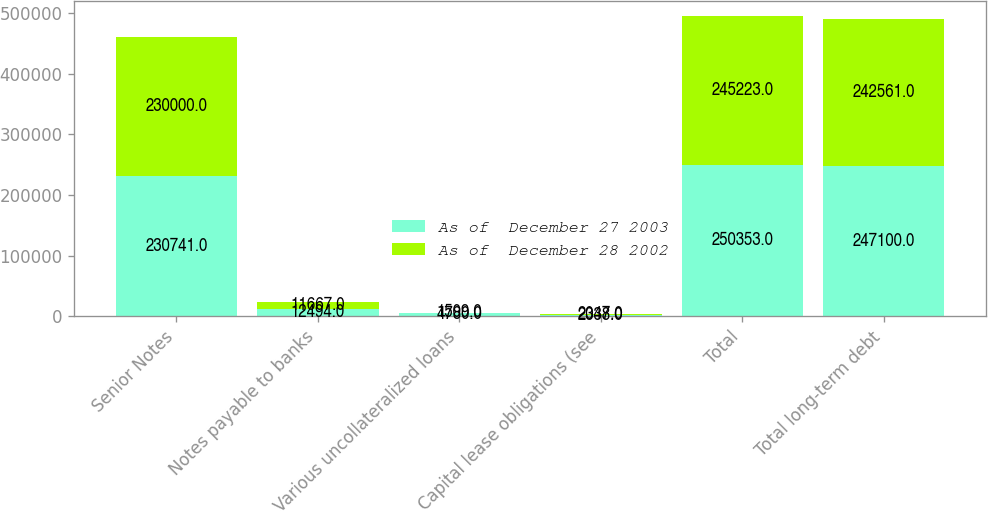Convert chart. <chart><loc_0><loc_0><loc_500><loc_500><stacked_bar_chart><ecel><fcel>Senior Notes<fcel>Notes payable to banks<fcel>Various uncollateralized loans<fcel>Capital lease obligations (see<fcel>Total<fcel>Total long-term debt<nl><fcel>As of  December 27 2003<fcel>230741<fcel>12494<fcel>4780<fcel>2338<fcel>250353<fcel>247100<nl><fcel>As of  December 28 2002<fcel>230000<fcel>11667<fcel>1509<fcel>2047<fcel>245223<fcel>242561<nl></chart> 